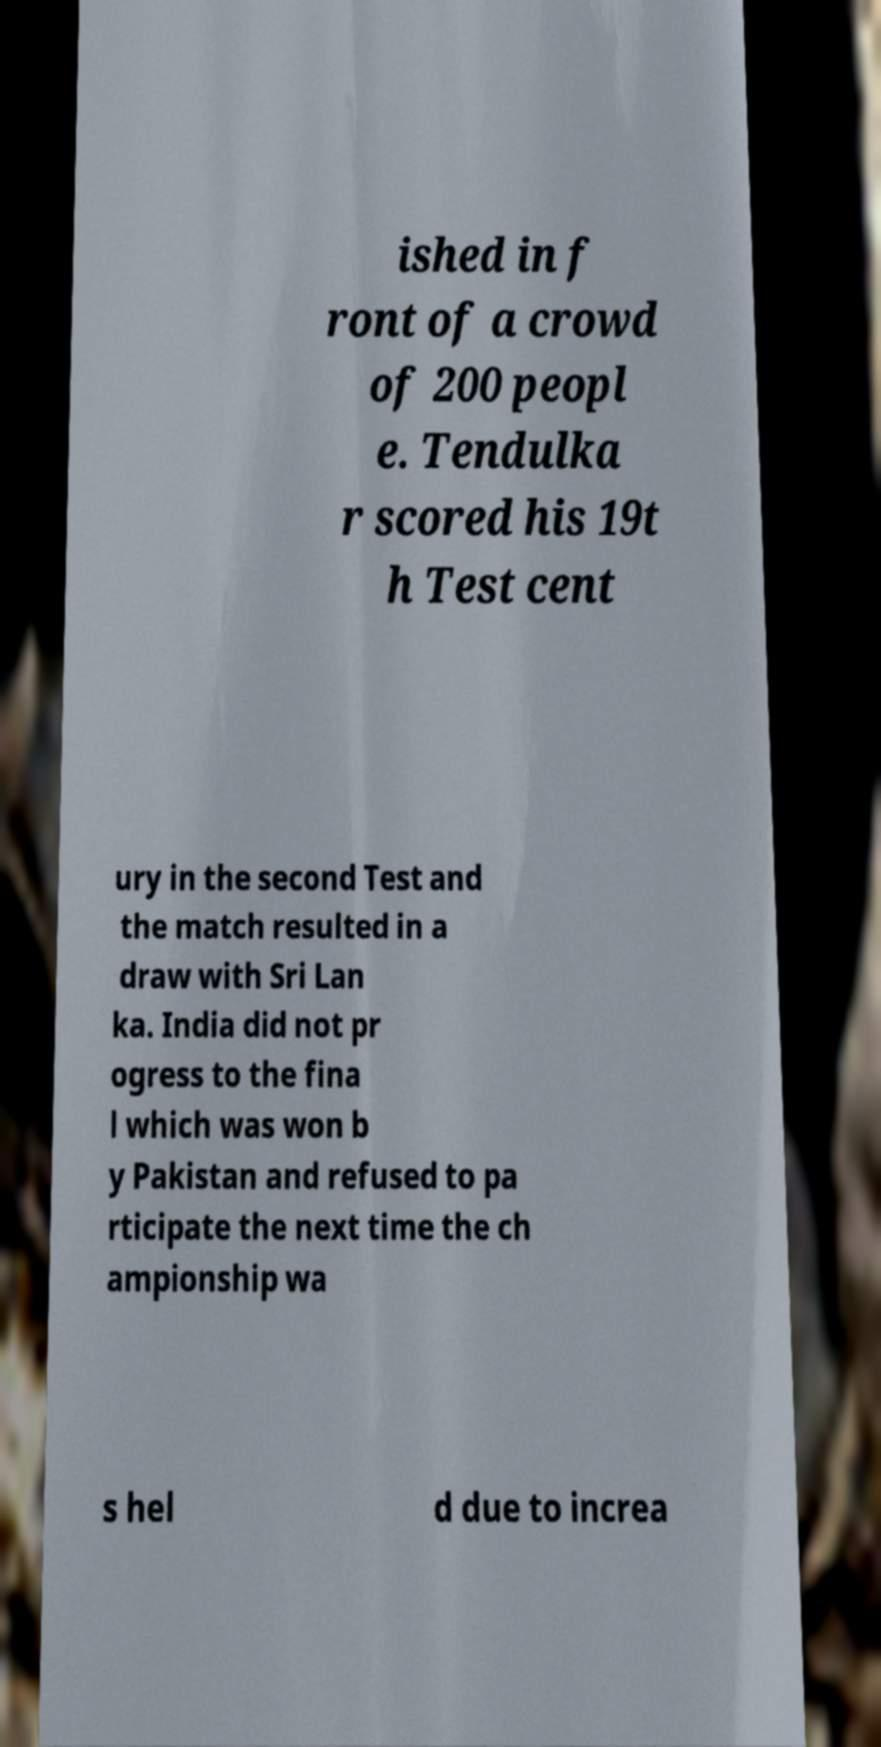For documentation purposes, I need the text within this image transcribed. Could you provide that? ished in f ront of a crowd of 200 peopl e. Tendulka r scored his 19t h Test cent ury in the second Test and the match resulted in a draw with Sri Lan ka. India did not pr ogress to the fina l which was won b y Pakistan and refused to pa rticipate the next time the ch ampionship wa s hel d due to increa 